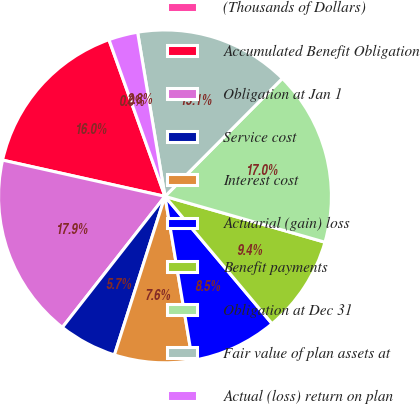Convert chart. <chart><loc_0><loc_0><loc_500><loc_500><pie_chart><fcel>(Thousands of Dollars)<fcel>Accumulated Benefit Obligation<fcel>Obligation at Jan 1<fcel>Service cost<fcel>Interest cost<fcel>Actuarial (gain) loss<fcel>Benefit payments<fcel>Obligation at Dec 31<fcel>Fair value of plan assets at<fcel>Actual (loss) return on plan<nl><fcel>0.01%<fcel>16.03%<fcel>17.92%<fcel>5.66%<fcel>7.55%<fcel>8.49%<fcel>9.43%<fcel>16.98%<fcel>15.09%<fcel>2.83%<nl></chart> 